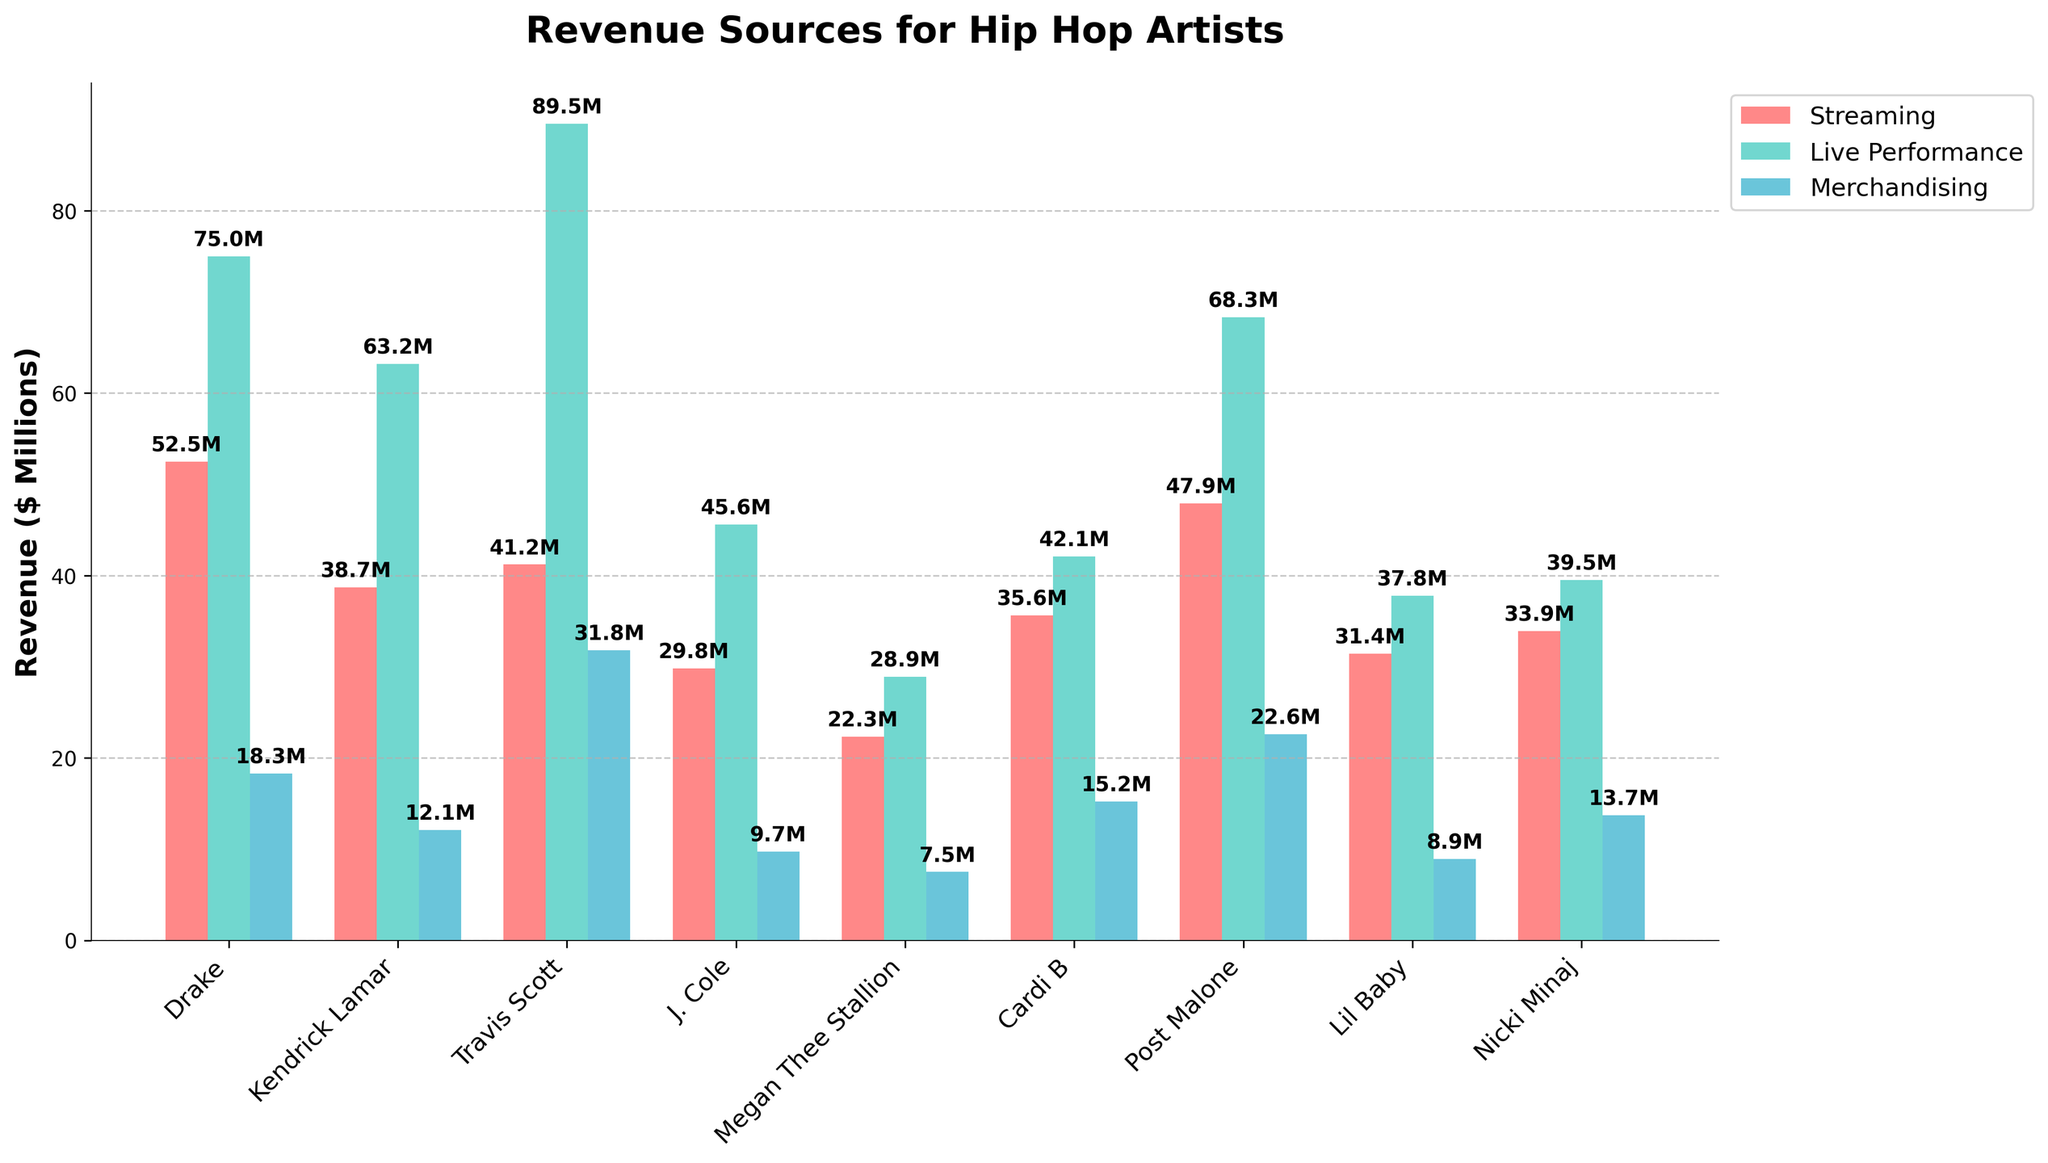Which artist has the highest live performance revenue? Look at the green bars representing live performance revenue. The artist with the tallest green bar is Travis Scott.
Answer: Travis Scott Which artist has the lowest streaming revenue? Look at the red bars representing streaming revenue. The artist with the shortest red bar is Megan Thee Stallion.
Answer: Megan Thee Stallion What is the average merchandising revenue for Drake and Cardi B? Sum Drake's merchandising revenue (18.3M) and Cardi B's merchandising revenue (15.2M) to get 33.5M. Divide by 2 to get the average: 33.5M / 2 = 16.75M.
Answer: 16.75M Which artist earns more from live performances than streaming? Compare the heights of the green and red bars for each artist. Travis Scott, Kendrick Lamar, and J. Cole have taller green bars (live performance) than red bars (streaming).
Answer: Travis Scott, Kendrick Lamar, J. Cole How much more does Post Malone earn from live performances than merchandising? Subtract Post Malone's merchandising revenue (22.6M) from his live performance revenue (68.3M): 68.3M - 22.6M = 45.7M.
Answer: 45.7M Does Nicki Minaj earn more from streaming or merchandising? Compare the height of the red bar (streaming) and the blue bar (merchandising) for Nicki Minaj. The red bar is taller.
Answer: Streaming What is the total revenue from streaming for all artists combined? Sum the streaming revenues for all artists: 52.5 + 38.7 + 41.2 + 29.8 + 22.3 + 35.6 + 47.9 + 31.4 + 33.9 = 333.3M.
Answer: 333.3M In terms of merchandising revenue, which artist ranks third highest? Identify the heights of the blue bars. Travis Scott has the highest, followed by Post Malone, and then Drake.
Answer: Drake Between Megan Thee Stallion and Cardi B, which artist has a higher live performance revenue? Compare the heights of the green bars for Megan Thee Stallion and Cardi B. Cardi B's bar is taller.
Answer: Cardi B Which artist has nearly equal streaming and live performance revenues? Look for artists whose red and green bars are similar in height. Drake's streaming (52.5M) and live performance (75M) revenues are relatively close compared to other artists.
Answer: Drake 